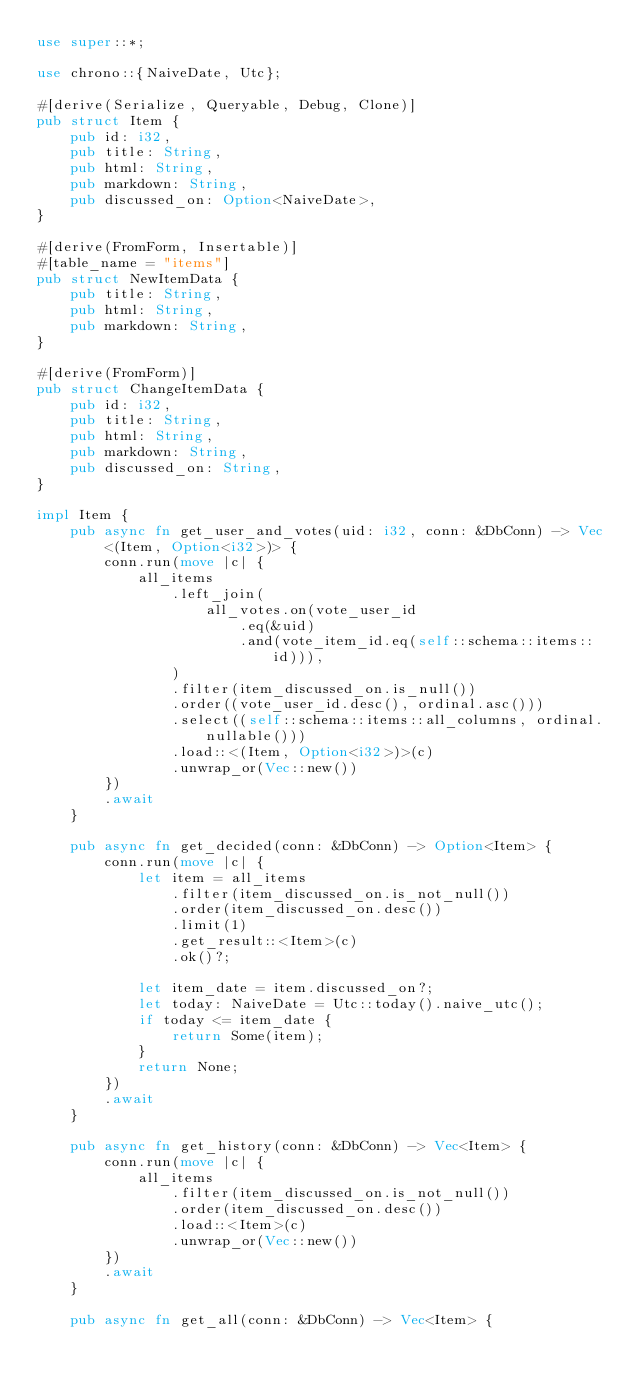<code> <loc_0><loc_0><loc_500><loc_500><_Rust_>use super::*;

use chrono::{NaiveDate, Utc};

#[derive(Serialize, Queryable, Debug, Clone)]
pub struct Item {
    pub id: i32,
    pub title: String,
    pub html: String,
    pub markdown: String,
    pub discussed_on: Option<NaiveDate>,
}

#[derive(FromForm, Insertable)]
#[table_name = "items"]
pub struct NewItemData {
    pub title: String,
    pub html: String,
    pub markdown: String,
}

#[derive(FromForm)]
pub struct ChangeItemData {
    pub id: i32,
    pub title: String,
    pub html: String,
    pub markdown: String,
    pub discussed_on: String,
}

impl Item {
    pub async fn get_user_and_votes(uid: i32, conn: &DbConn) -> Vec<(Item, Option<i32>)> {
        conn.run(move |c| {
            all_items
                .left_join(
                    all_votes.on(vote_user_id
                        .eq(&uid)
                        .and(vote_item_id.eq(self::schema::items::id))),
                )
                .filter(item_discussed_on.is_null())
                .order((vote_user_id.desc(), ordinal.asc()))
                .select((self::schema::items::all_columns, ordinal.nullable()))
                .load::<(Item, Option<i32>)>(c)
                .unwrap_or(Vec::new())
        })
        .await
    }

    pub async fn get_decided(conn: &DbConn) -> Option<Item> {
        conn.run(move |c| {
            let item = all_items
                .filter(item_discussed_on.is_not_null())
                .order(item_discussed_on.desc())
                .limit(1)
                .get_result::<Item>(c)
                .ok()?;

            let item_date = item.discussed_on?;
            let today: NaiveDate = Utc::today().naive_utc();
            if today <= item_date {
                return Some(item);
            }
            return None;
        })
        .await
    }

    pub async fn get_history(conn: &DbConn) -> Vec<Item> {
        conn.run(move |c| {
            all_items
                .filter(item_discussed_on.is_not_null())
                .order(item_discussed_on.desc())
                .load::<Item>(c)
                .unwrap_or(Vec::new())
        })
        .await
    }

    pub async fn get_all(conn: &DbConn) -> Vec<Item> {</code> 